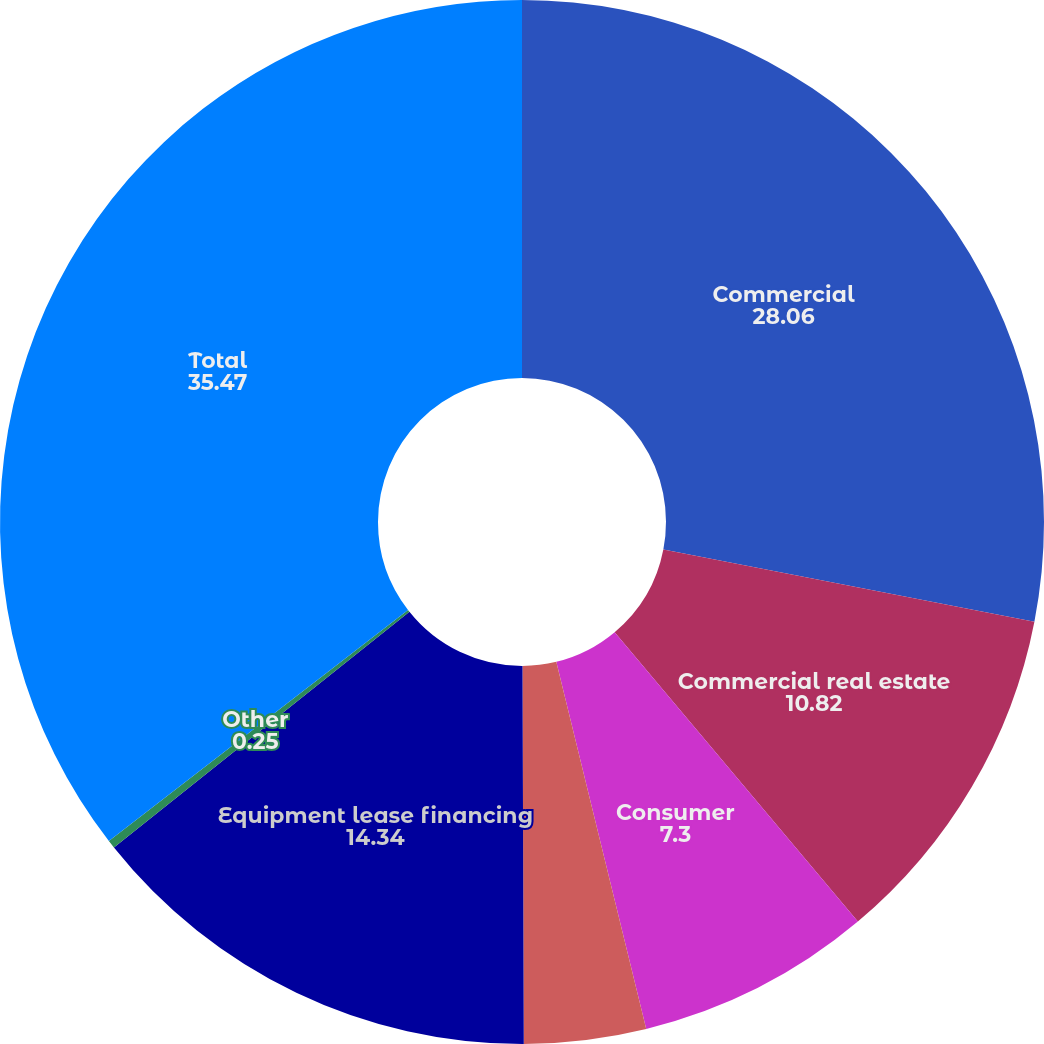Convert chart. <chart><loc_0><loc_0><loc_500><loc_500><pie_chart><fcel>Commercial<fcel>Commercial real estate<fcel>Consumer<fcel>Residential real estate<fcel>Equipment lease financing<fcel>Other<fcel>Total<nl><fcel>28.06%<fcel>10.82%<fcel>7.3%<fcel>3.77%<fcel>14.34%<fcel>0.25%<fcel>35.47%<nl></chart> 